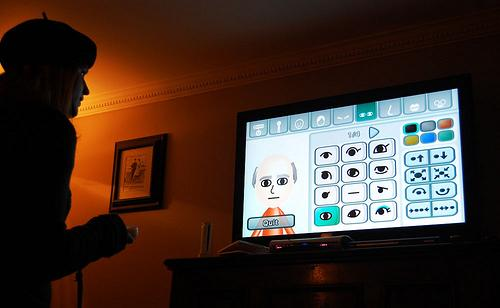Why are there eyes on the screen?

Choices:
A) people watching
B) getting glasses
C) playing solitaire
D) customizing avatar customizing avatar 